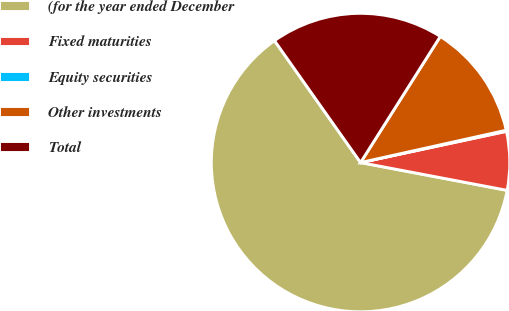<chart> <loc_0><loc_0><loc_500><loc_500><pie_chart><fcel>(for the year ended December<fcel>Fixed maturities<fcel>Equity securities<fcel>Other investments<fcel>Total<nl><fcel>62.24%<fcel>6.34%<fcel>0.12%<fcel>12.55%<fcel>18.76%<nl></chart> 